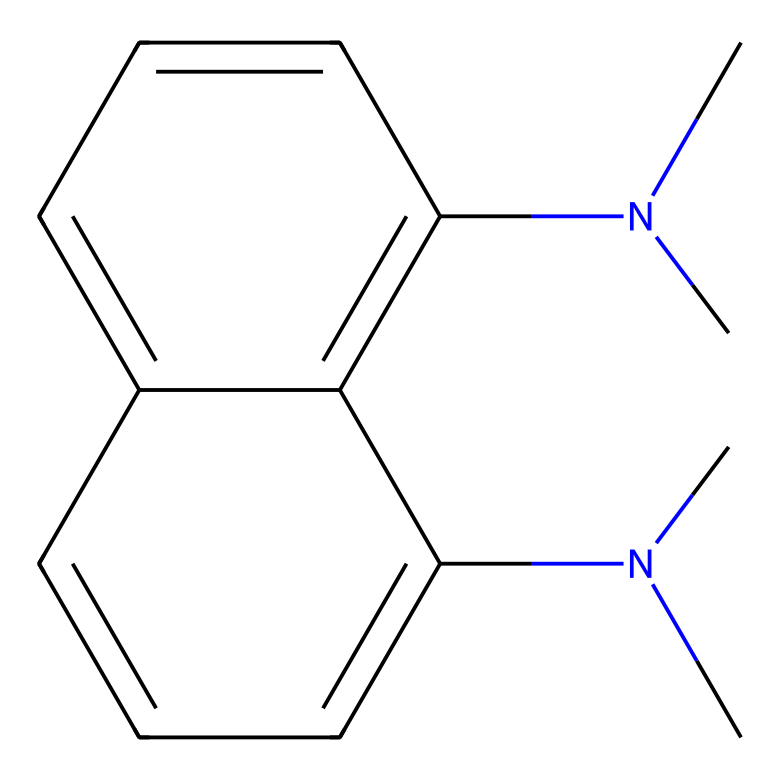What is the molecular formula of this compound? To determine the molecular formula, we count the number of each type of atom present in the structure. The given SMILES representation indicates 16 carbon (C) atoms, 20 hydrogen (H) atoms, and 2 nitrogen (N) atoms. Thus, the molecular formula is C16H20N2.
Answer: C16H20N2 How many rings are present in the structure? By analyzing the connectivity of the atoms in the provided SMILES, we can identify any cyclic structures. The rings in this compound can be counted by looking for numbers that indicate bonded atoms forming a loop. There are two rings indicated in the structure.
Answer: 2 What type of nitrogen substituents are present? The nitrogen atoms here are part of a secondary amine functionality, indicated by the structure where the nitrogen is bonded to two carbon groups (C). Each nitrogen in the molecule carries one alkyl (methyl) group.
Answer: secondary amine Is this compound considered a superbase? Superbase characteristics typically involve the ability to deprotonate even very weak acids, often related to the presence of nitrogen atoms in specific arrangements. This compound, having two nitrogen atoms, is classified as a superbase used in studying acidic pollutants.
Answer: yes What is the role of superbases like this one in atmospheric chemistry? Superbases can facilitate the deprotonation of atmospheric pollutants, leading to increased reactivity and transformations in environmental chemistry. They enhance the understanding of reaction mechanisms involving acid-base interactions.
Answer: facilitate reactions How does the molecular structure contribute to its basicity? The basicity of this compound is influenced by the presence of nitrogen atoms with lone pairs, allowing them to accept protons (H+). The arrangement of these nitrogens in a symmetrical structure can stabilize the conjugate acid form, enhancing basicity.
Answer: lone pairs on nitrogen 